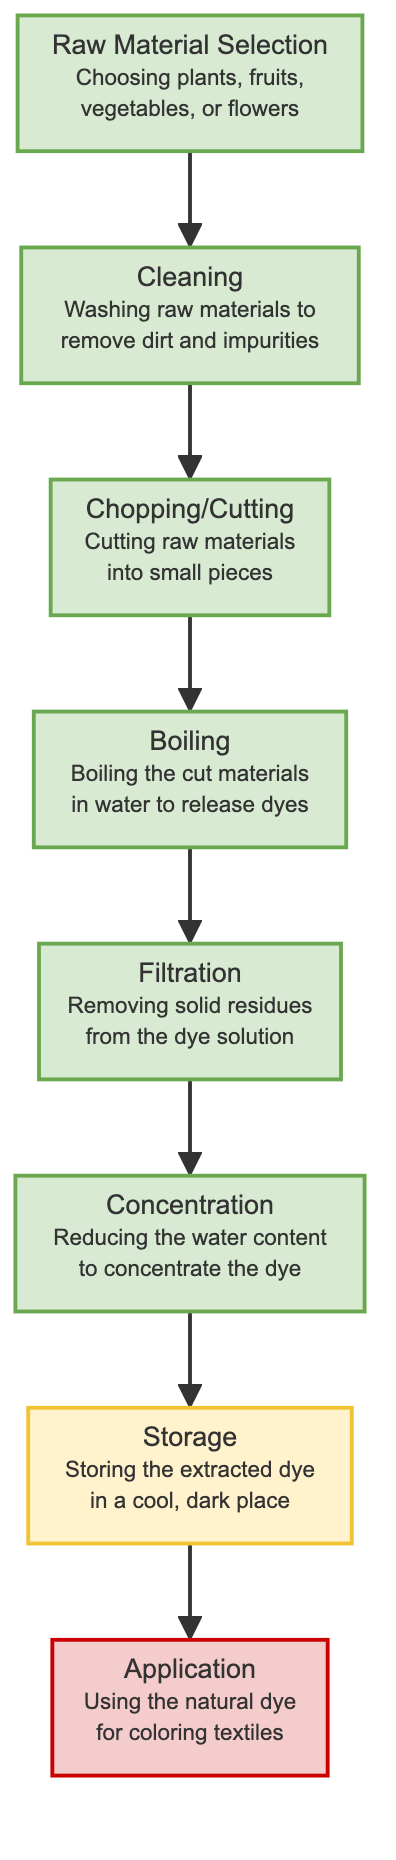What is the first step in the natural dye extraction process? According to the diagram, the first step is "Raw Material Selection", which involves choosing plants, fruits, vegetables, or flowers.
Answer: Raw Material Selection How many steps are there in the natural dye extraction process? The diagram displays a total of 8 distinct steps, from "Raw Material Selection" to "Application".
Answer: 8 What step comes immediately after "Chopping/Cutting"? Following "Chopping/Cutting", the next step indicated in the diagram is "Boiling".
Answer: Boiling Which step involves storing the extracted dye? The diagram shows that "Storage" is the step dedicated to storing the extracted dye in a cool, dark place.
Answer: Storage What is the connection between "Filtration" and "Concentration"? "Filtration" leads directly into "Concentration", indicating that after filtering out solid residues, the process moves on to reduce the water content to concentrate the dye.
Answer: → What type of node is "Application"? The node "Application" is marked as an applicationNode, indicating its role in the process is focused on the utilization of the dye for coloring textiles.
Answer: applicationNode What is the purpose of the "Cleaning" step? The "Cleaning" step is specifically aimed at washing raw materials to remove dirt and impurities before further processing.
Answer: Removing dirt and impurities Explain the flow from "Boiling" to "Filtration" in the extraction process. In the natural dye extraction process, after "Boiling" the cut materials to release dyes, the next step is "Filtration", where solid residues are removed from the dye solution, allowing for a clean dye to be concentrated in the following steps.
Answer: Boiling → Filtration What process occurs before "Storage"? Prior to "Storage", the dye undergoes "Concentration", where the water content is reduced to make the dye more potent before it is stored.
Answer: Concentration 